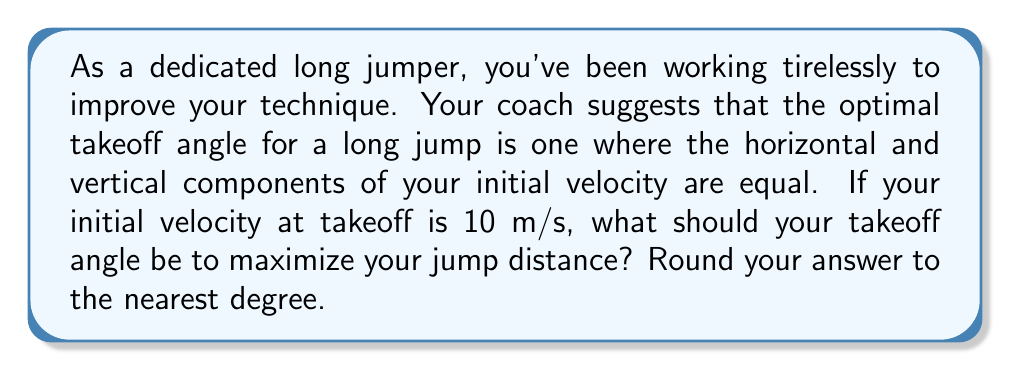Show me your answer to this math problem. Let's approach this step-by-step:

1) Let $\theta$ be the takeoff angle we're looking for.

2) We're told that the optimal angle is when the horizontal and vertical components of the initial velocity are equal. In vector notation, this means:

   $v_x = v_y$

3) We know from trigonometry that:
   
   $v_x = v \cos\theta$
   $v_y = v \sin\theta$

   Where $v$ is the total initial velocity (10 m/s in this case).

4) For these to be equal:

   $v \cos\theta = v \sin\theta$

5) The $v$ cancels out on both sides:

   $\cos\theta = \sin\theta$

6) We can solve this by dividing both sides by $\cos\theta$:

   $\frac{\sin\theta}{\cos\theta} = 1$

7) We recognize $\frac{\sin\theta}{\cos\theta}$ as $\tan\theta$, so:

   $\tan\theta = 1$

8) To solve for $\theta$, we take the inverse tangent (arctan or $\tan^{-1}$) of both sides:

   $\theta = \tan^{-1}(1)$

9) $\tan^{-1}(1) = 45°$

Therefore, the optimal takeoff angle is 45°.

This result aligns with physics principles: in a vacuum, 45° would always be the optimal angle for projectile motion to achieve maximum range. In reality, factors like air resistance might slightly alter this, but 45° remains a good approximation for many situations, including the long jump.
Answer: 45° 